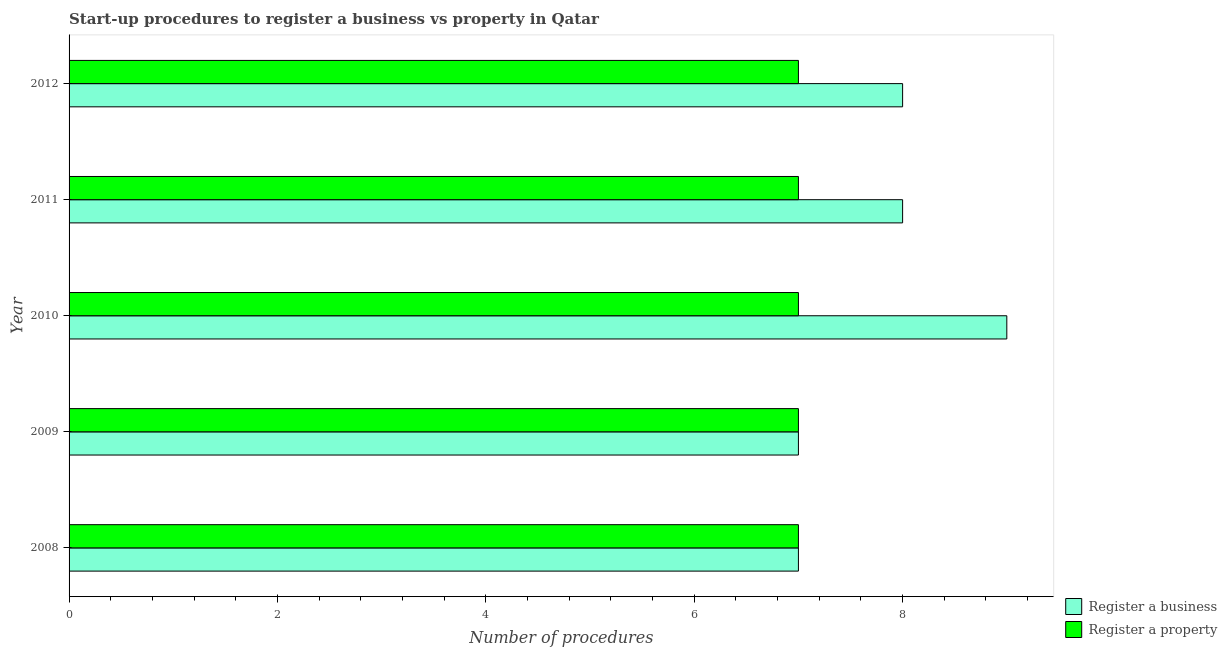Are the number of bars per tick equal to the number of legend labels?
Your answer should be very brief. Yes. Are the number of bars on each tick of the Y-axis equal?
Your answer should be compact. Yes. How many bars are there on the 5th tick from the top?
Your response must be concise. 2. How many bars are there on the 1st tick from the bottom?
Provide a succinct answer. 2. In how many cases, is the number of bars for a given year not equal to the number of legend labels?
Offer a terse response. 0. What is the number of procedures to register a business in 2011?
Offer a terse response. 8. Across all years, what is the maximum number of procedures to register a property?
Your response must be concise. 7. Across all years, what is the minimum number of procedures to register a business?
Your answer should be compact. 7. What is the total number of procedures to register a business in the graph?
Your answer should be very brief. 39. What is the difference between the number of procedures to register a property in 2009 and the number of procedures to register a business in 2012?
Offer a very short reply. -1. What is the average number of procedures to register a business per year?
Provide a short and direct response. 7.8. In the year 2012, what is the difference between the number of procedures to register a business and number of procedures to register a property?
Keep it short and to the point. 1. In how many years, is the number of procedures to register a business greater than 4 ?
Your answer should be very brief. 5. Is the difference between the number of procedures to register a property in 2010 and 2012 greater than the difference between the number of procedures to register a business in 2010 and 2012?
Provide a succinct answer. No. What is the difference between the highest and the lowest number of procedures to register a business?
Offer a very short reply. 2. In how many years, is the number of procedures to register a property greater than the average number of procedures to register a property taken over all years?
Give a very brief answer. 0. What does the 1st bar from the top in 2010 represents?
Offer a very short reply. Register a property. What does the 1st bar from the bottom in 2010 represents?
Keep it short and to the point. Register a business. Are all the bars in the graph horizontal?
Your answer should be compact. Yes. How many years are there in the graph?
Provide a succinct answer. 5. What is the difference between two consecutive major ticks on the X-axis?
Provide a succinct answer. 2. What is the title of the graph?
Your response must be concise. Start-up procedures to register a business vs property in Qatar. Does "Constant 2005 US$" appear as one of the legend labels in the graph?
Your answer should be very brief. No. What is the label or title of the X-axis?
Ensure brevity in your answer.  Number of procedures. What is the Number of procedures in Register a property in 2008?
Your answer should be compact. 7. What is the Number of procedures in Register a property in 2011?
Provide a short and direct response. 7. What is the Number of procedures of Register a property in 2012?
Provide a short and direct response. 7. Across all years, what is the maximum Number of procedures of Register a business?
Give a very brief answer. 9. Across all years, what is the maximum Number of procedures of Register a property?
Ensure brevity in your answer.  7. Across all years, what is the minimum Number of procedures in Register a property?
Your response must be concise. 7. What is the total Number of procedures in Register a business in the graph?
Keep it short and to the point. 39. What is the total Number of procedures in Register a property in the graph?
Provide a short and direct response. 35. What is the difference between the Number of procedures in Register a property in 2008 and that in 2009?
Provide a succinct answer. 0. What is the difference between the Number of procedures in Register a business in 2008 and that in 2010?
Your answer should be compact. -2. What is the difference between the Number of procedures in Register a property in 2008 and that in 2010?
Provide a succinct answer. 0. What is the difference between the Number of procedures of Register a business in 2008 and that in 2011?
Provide a short and direct response. -1. What is the difference between the Number of procedures of Register a property in 2008 and that in 2011?
Keep it short and to the point. 0. What is the difference between the Number of procedures of Register a business in 2008 and that in 2012?
Offer a very short reply. -1. What is the difference between the Number of procedures of Register a property in 2009 and that in 2010?
Keep it short and to the point. 0. What is the difference between the Number of procedures in Register a business in 2009 and that in 2011?
Your response must be concise. -1. What is the difference between the Number of procedures of Register a property in 2009 and that in 2011?
Keep it short and to the point. 0. What is the difference between the Number of procedures in Register a property in 2009 and that in 2012?
Ensure brevity in your answer.  0. What is the difference between the Number of procedures of Register a property in 2010 and that in 2011?
Your answer should be compact. 0. What is the difference between the Number of procedures of Register a business in 2010 and that in 2012?
Offer a very short reply. 1. What is the difference between the Number of procedures in Register a property in 2010 and that in 2012?
Keep it short and to the point. 0. What is the difference between the Number of procedures in Register a business in 2011 and that in 2012?
Provide a short and direct response. 0. What is the difference between the Number of procedures of Register a property in 2011 and that in 2012?
Provide a short and direct response. 0. What is the difference between the Number of procedures in Register a business in 2008 and the Number of procedures in Register a property in 2011?
Your answer should be compact. 0. What is the difference between the Number of procedures in Register a business in 2009 and the Number of procedures in Register a property in 2010?
Provide a succinct answer. 0. What is the difference between the Number of procedures in Register a business in 2009 and the Number of procedures in Register a property in 2011?
Make the answer very short. 0. What is the difference between the Number of procedures of Register a business in 2009 and the Number of procedures of Register a property in 2012?
Your answer should be very brief. 0. What is the difference between the Number of procedures of Register a business in 2010 and the Number of procedures of Register a property in 2011?
Your response must be concise. 2. What is the average Number of procedures in Register a property per year?
Your response must be concise. 7. In the year 2011, what is the difference between the Number of procedures of Register a business and Number of procedures of Register a property?
Offer a terse response. 1. What is the ratio of the Number of procedures of Register a property in 2008 to that in 2010?
Provide a succinct answer. 1. What is the ratio of the Number of procedures in Register a business in 2008 to that in 2011?
Make the answer very short. 0.88. What is the ratio of the Number of procedures of Register a property in 2008 to that in 2011?
Your answer should be very brief. 1. What is the ratio of the Number of procedures of Register a business in 2008 to that in 2012?
Your response must be concise. 0.88. What is the ratio of the Number of procedures of Register a property in 2009 to that in 2010?
Your response must be concise. 1. What is the ratio of the Number of procedures of Register a business in 2009 to that in 2011?
Give a very brief answer. 0.88. What is the ratio of the Number of procedures of Register a property in 2009 to that in 2011?
Provide a succinct answer. 1. What is the ratio of the Number of procedures of Register a business in 2009 to that in 2012?
Provide a succinct answer. 0.88. What is the ratio of the Number of procedures of Register a business in 2010 to that in 2011?
Your answer should be very brief. 1.12. What is the ratio of the Number of procedures in Register a property in 2010 to that in 2011?
Provide a short and direct response. 1. What is the ratio of the Number of procedures in Register a business in 2010 to that in 2012?
Ensure brevity in your answer.  1.12. What is the difference between the highest and the second highest Number of procedures of Register a business?
Keep it short and to the point. 1. What is the difference between the highest and the second highest Number of procedures in Register a property?
Your answer should be compact. 0. What is the difference between the highest and the lowest Number of procedures of Register a business?
Your answer should be very brief. 2. What is the difference between the highest and the lowest Number of procedures of Register a property?
Your response must be concise. 0. 